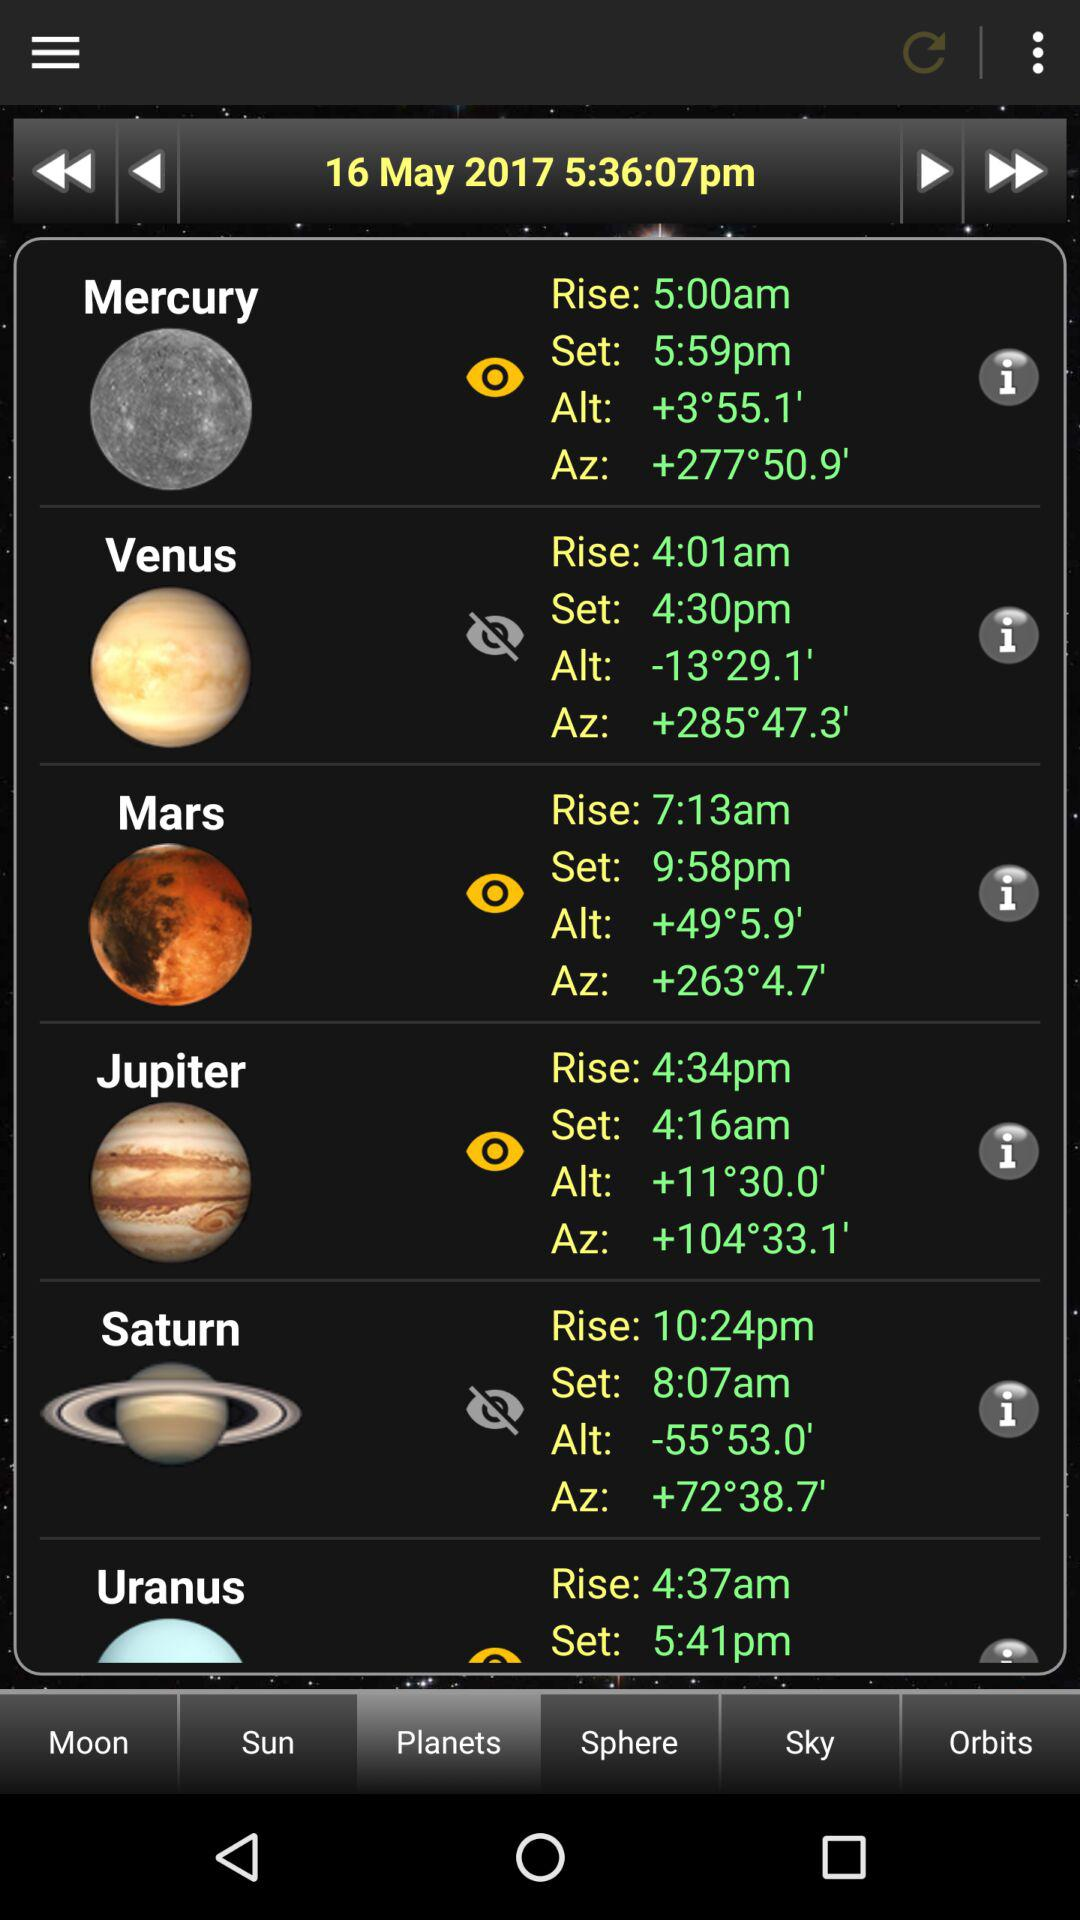What is Mercury's rise time? The Mercury's rise time is 5:00am. 